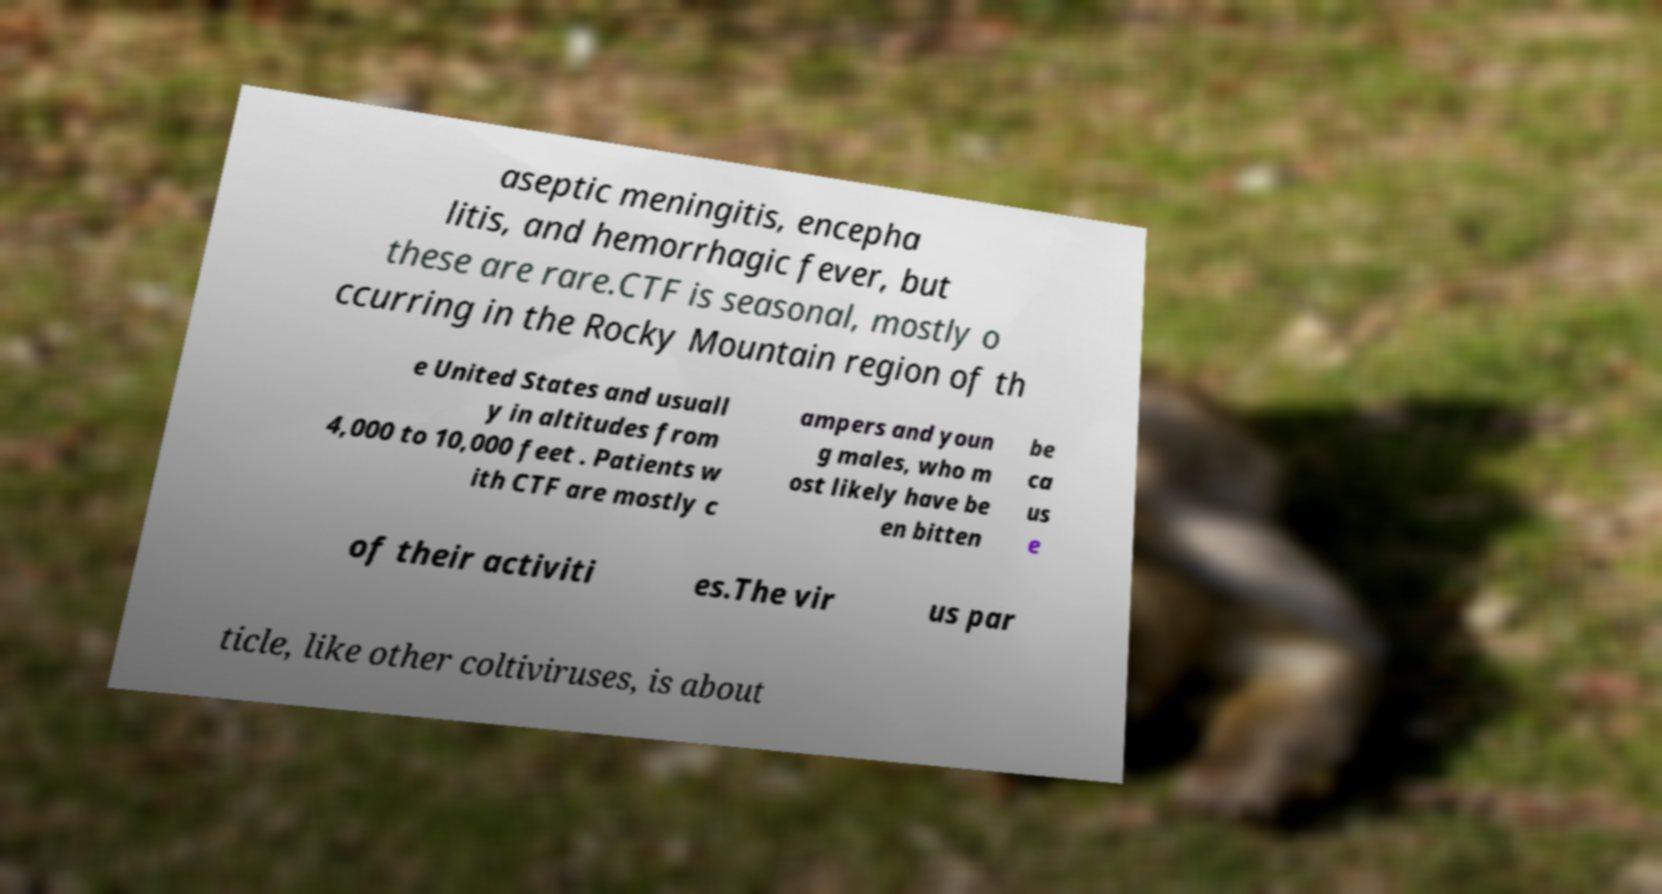Could you assist in decoding the text presented in this image and type it out clearly? aseptic meningitis, encepha litis, and hemorrhagic fever, but these are rare.CTF is seasonal, mostly o ccurring in the Rocky Mountain region of th e United States and usuall y in altitudes from 4,000 to 10,000 feet . Patients w ith CTF are mostly c ampers and youn g males, who m ost likely have be en bitten be ca us e of their activiti es.The vir us par ticle, like other coltiviruses, is about 